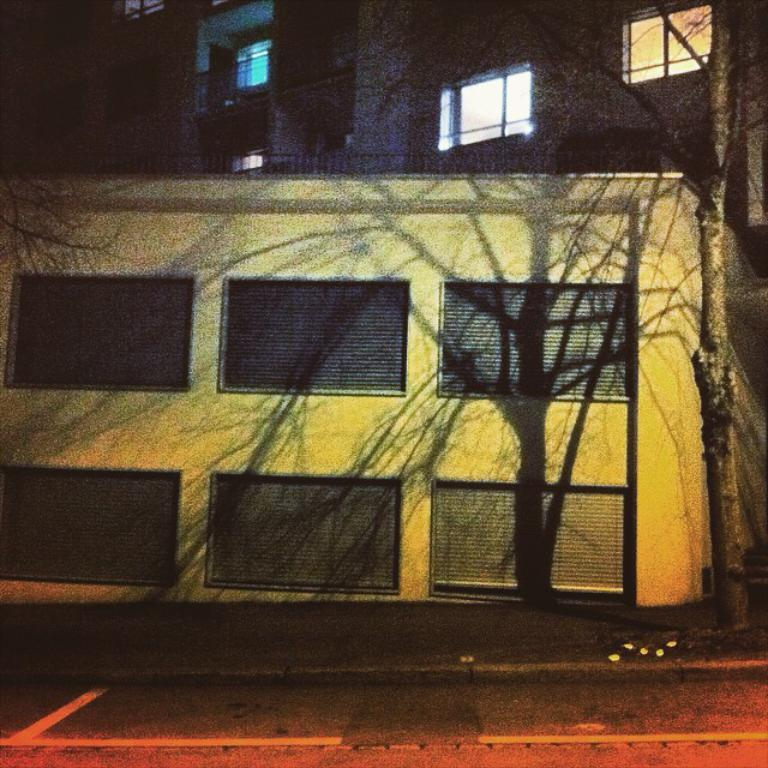What type of structures can be seen in the image? There are buildings in the image. What other natural elements are present in the image? There are trees in the image. What feature can be seen on the buildings and possibly other structures? There are windows in the image. Can you determine the time of day based on the image? The image may have been taken during the night, as there is a possibility that it is dark. How many birds can be seen flying near the clam in the image? There are no birds or clams present in the image; it features buildings and trees. 